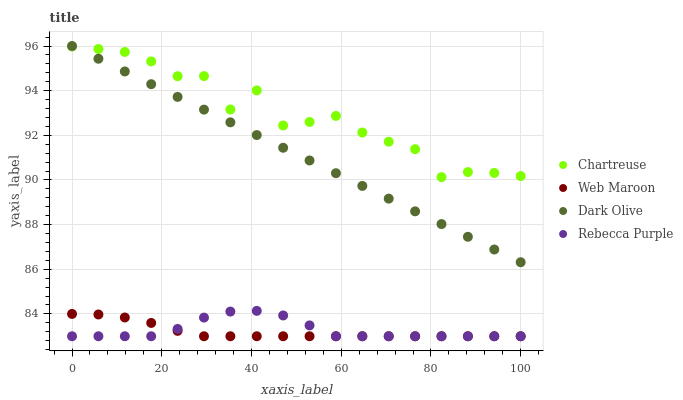Does Web Maroon have the minimum area under the curve?
Answer yes or no. Yes. Does Chartreuse have the maximum area under the curve?
Answer yes or no. Yes. Does Dark Olive have the minimum area under the curve?
Answer yes or no. No. Does Dark Olive have the maximum area under the curve?
Answer yes or no. No. Is Dark Olive the smoothest?
Answer yes or no. Yes. Is Chartreuse the roughest?
Answer yes or no. Yes. Is Web Maroon the smoothest?
Answer yes or no. No. Is Web Maroon the roughest?
Answer yes or no. No. Does Web Maroon have the lowest value?
Answer yes or no. Yes. Does Dark Olive have the lowest value?
Answer yes or no. No. Does Dark Olive have the highest value?
Answer yes or no. Yes. Does Web Maroon have the highest value?
Answer yes or no. No. Is Rebecca Purple less than Dark Olive?
Answer yes or no. Yes. Is Dark Olive greater than Web Maroon?
Answer yes or no. Yes. Does Rebecca Purple intersect Web Maroon?
Answer yes or no. Yes. Is Rebecca Purple less than Web Maroon?
Answer yes or no. No. Is Rebecca Purple greater than Web Maroon?
Answer yes or no. No. Does Rebecca Purple intersect Dark Olive?
Answer yes or no. No. 